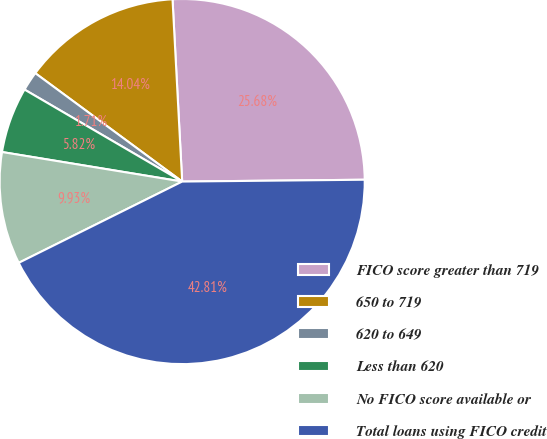Convert chart to OTSL. <chart><loc_0><loc_0><loc_500><loc_500><pie_chart><fcel>FICO score greater than 719<fcel>650 to 719<fcel>620 to 649<fcel>Less than 620<fcel>No FICO score available or<fcel>Total loans using FICO credit<nl><fcel>25.68%<fcel>14.04%<fcel>1.71%<fcel>5.82%<fcel>9.93%<fcel>42.81%<nl></chart> 